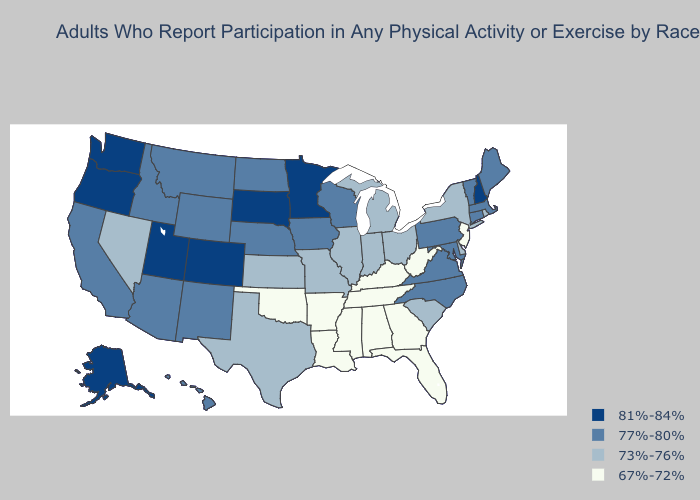What is the lowest value in states that border Arizona?
Be succinct. 73%-76%. Does Arizona have the lowest value in the West?
Concise answer only. No. Does Missouri have the lowest value in the USA?
Give a very brief answer. No. Name the states that have a value in the range 73%-76%?
Be succinct. Delaware, Illinois, Indiana, Kansas, Michigan, Missouri, Nevada, New York, Ohio, Rhode Island, South Carolina, Texas. Among the states that border Georgia , does Florida have the highest value?
Write a very short answer. No. What is the lowest value in the West?
Quick response, please. 73%-76%. Does the first symbol in the legend represent the smallest category?
Be succinct. No. Among the states that border Georgia , which have the highest value?
Keep it brief. North Carolina. Does the first symbol in the legend represent the smallest category?
Be succinct. No. Does the map have missing data?
Keep it brief. No. Which states have the lowest value in the USA?
Concise answer only. Alabama, Arkansas, Florida, Georgia, Kentucky, Louisiana, Mississippi, New Jersey, Oklahoma, Tennessee, West Virginia. Name the states that have a value in the range 77%-80%?
Answer briefly. Arizona, California, Connecticut, Hawaii, Idaho, Iowa, Maine, Maryland, Massachusetts, Montana, Nebraska, New Mexico, North Carolina, North Dakota, Pennsylvania, Vermont, Virginia, Wisconsin, Wyoming. What is the lowest value in the West?
Short answer required. 73%-76%. 